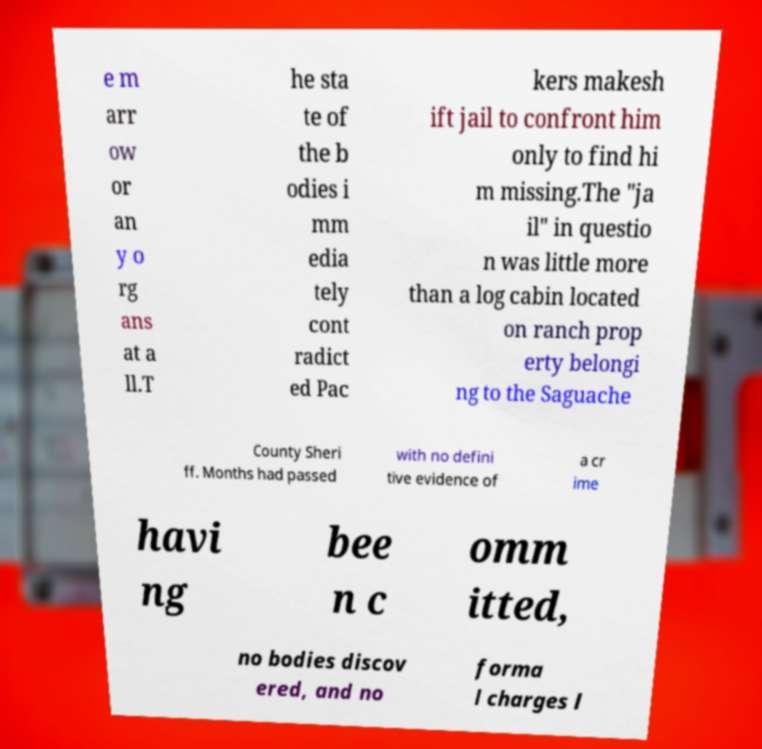Can you accurately transcribe the text from the provided image for me? e m arr ow or an y o rg ans at a ll.T he sta te of the b odies i mm edia tely cont radict ed Pac kers makesh ift jail to confront him only to find hi m missing.The "ja il" in questio n was little more than a log cabin located on ranch prop erty belongi ng to the Saguache County Sheri ff. Months had passed with no defini tive evidence of a cr ime havi ng bee n c omm itted, no bodies discov ered, and no forma l charges l 